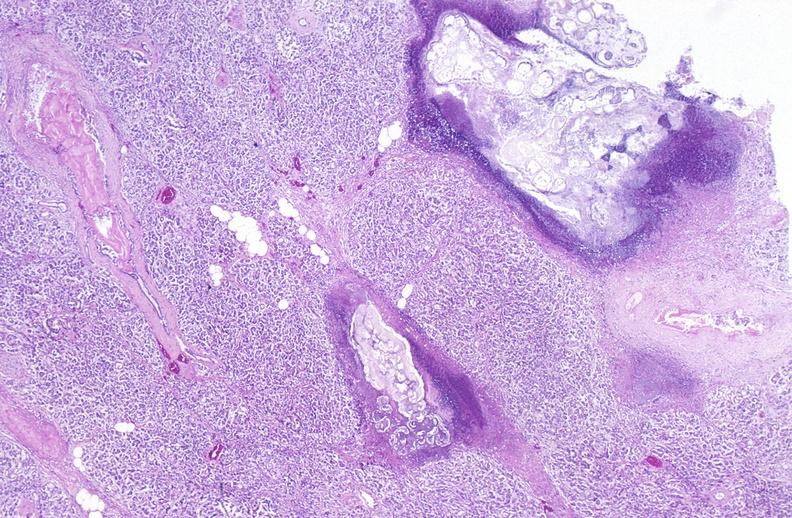what does this image show?
Answer the question using a single word or phrase. Pancreatic fat necrosis 